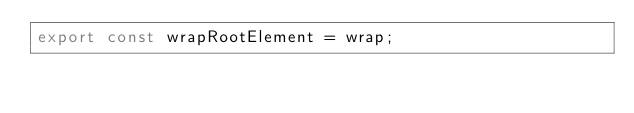<code> <loc_0><loc_0><loc_500><loc_500><_JavaScript_>export const wrapRootElement = wrap;</code> 